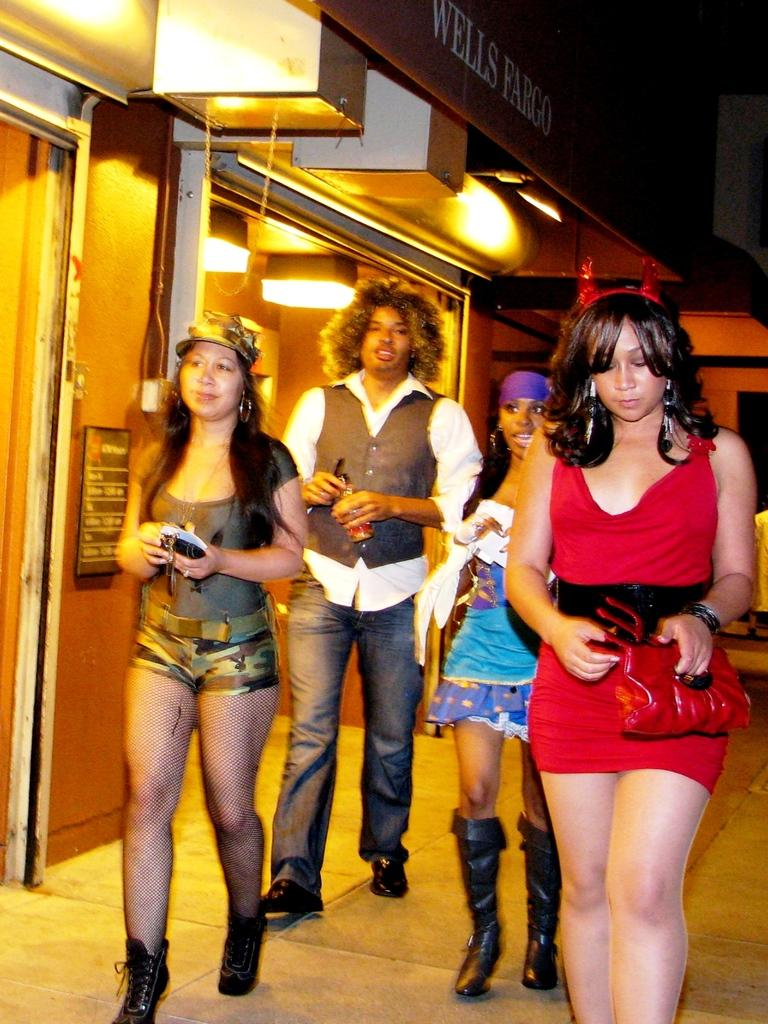What are the people in the image doing? The people in the image are standing on the footpath. What structure can be seen in the background of the image? There is a building in the image. What is written on the hoarding of the building? The hoarding of the building has "Wells Fargo" written on it. What type of body is visible in the image? There is no body visible in the image; it features people standing on a footpath and a building with a hoarding. Are there any animals in the image that might bite someone? There are no animals present in the image, so it is not possible to determine if any might bite someone. 